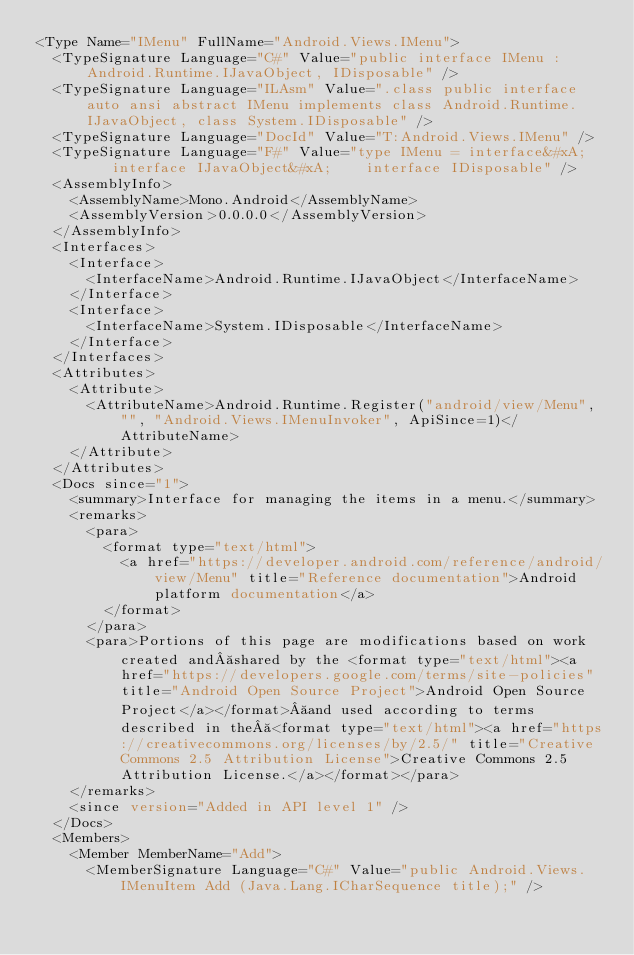<code> <loc_0><loc_0><loc_500><loc_500><_XML_><Type Name="IMenu" FullName="Android.Views.IMenu">
  <TypeSignature Language="C#" Value="public interface IMenu : Android.Runtime.IJavaObject, IDisposable" />
  <TypeSignature Language="ILAsm" Value=".class public interface auto ansi abstract IMenu implements class Android.Runtime.IJavaObject, class System.IDisposable" />
  <TypeSignature Language="DocId" Value="T:Android.Views.IMenu" />
  <TypeSignature Language="F#" Value="type IMenu = interface&#xA;    interface IJavaObject&#xA;    interface IDisposable" />
  <AssemblyInfo>
    <AssemblyName>Mono.Android</AssemblyName>
    <AssemblyVersion>0.0.0.0</AssemblyVersion>
  </AssemblyInfo>
  <Interfaces>
    <Interface>
      <InterfaceName>Android.Runtime.IJavaObject</InterfaceName>
    </Interface>
    <Interface>
      <InterfaceName>System.IDisposable</InterfaceName>
    </Interface>
  </Interfaces>
  <Attributes>
    <Attribute>
      <AttributeName>Android.Runtime.Register("android/view/Menu", "", "Android.Views.IMenuInvoker", ApiSince=1)</AttributeName>
    </Attribute>
  </Attributes>
  <Docs since="1">
    <summary>Interface for managing the items in a menu.</summary>
    <remarks>
      <para>
        <format type="text/html">
          <a href="https://developer.android.com/reference/android/view/Menu" title="Reference documentation">Android platform documentation</a>
        </format>
      </para>
      <para>Portions of this page are modifications based on work created and shared by the <format type="text/html"><a href="https://developers.google.com/terms/site-policies" title="Android Open Source Project">Android Open Source Project</a></format> and used according to terms described in the <format type="text/html"><a href="https://creativecommons.org/licenses/by/2.5/" title="Creative Commons 2.5 Attribution License">Creative Commons 2.5 Attribution License.</a></format></para>
    </remarks>
    <since version="Added in API level 1" />
  </Docs>
  <Members>
    <Member MemberName="Add">
      <MemberSignature Language="C#" Value="public Android.Views.IMenuItem Add (Java.Lang.ICharSequence title);" /></code> 